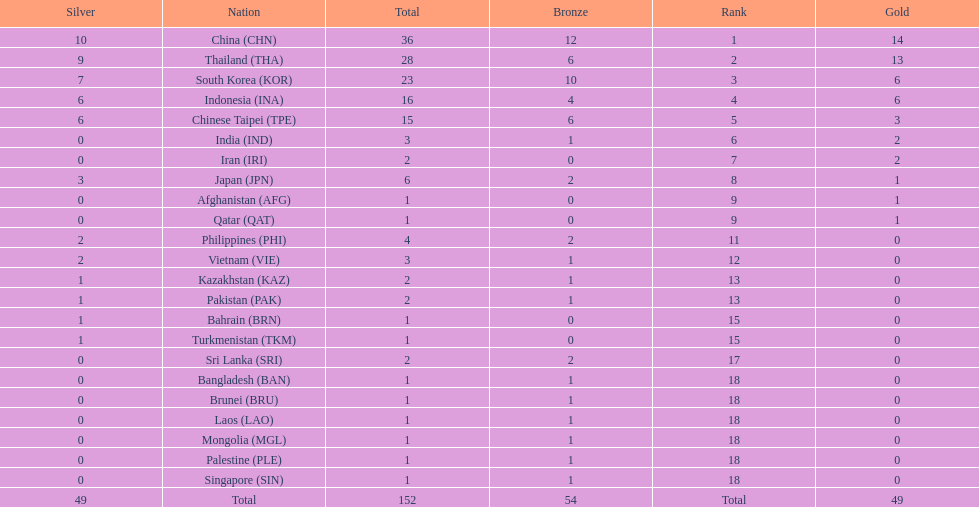How many combined silver medals did china, india, and japan earn ? 13. 